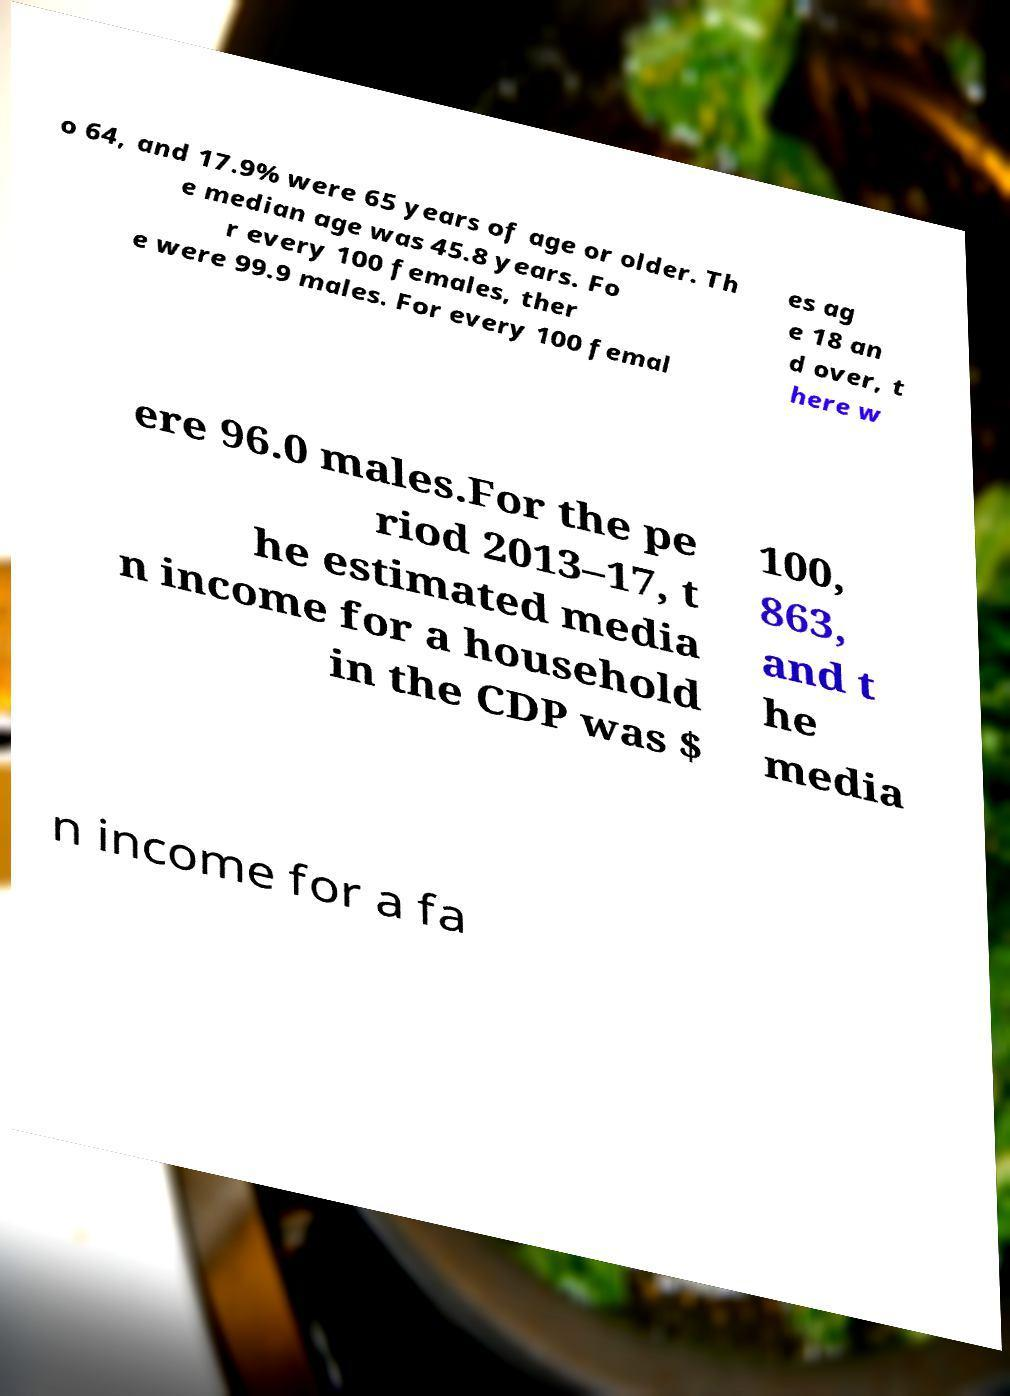Could you extract and type out the text from this image? o 64, and 17.9% were 65 years of age or older. Th e median age was 45.8 years. Fo r every 100 females, ther e were 99.9 males. For every 100 femal es ag e 18 an d over, t here w ere 96.0 males.For the pe riod 2013–17, t he estimated media n income for a household in the CDP was $ 100, 863, and t he media n income for a fa 